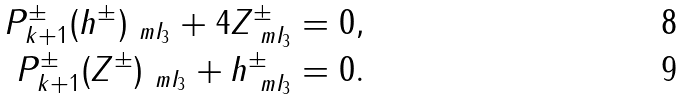Convert formula to latex. <formula><loc_0><loc_0><loc_500><loc_500>P ^ { \pm } _ { k + 1 } ( h ^ { \pm } ) _ { \ m I _ { 3 } } + 4 Z ^ { \pm } _ { \ m I _ { 3 } } & = 0 , \\ P ^ { \pm } _ { k + 1 } ( Z ^ { \pm } ) _ { \ m I _ { 3 } } + h ^ { \pm } _ { \ m I _ { 3 } } & = 0 .</formula> 